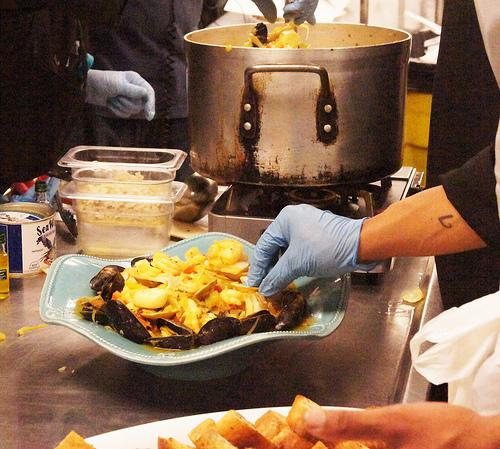Question: what else is this?
Choices:
A. A plate.
B. A placemat.
C. A napkin.
D. A bowl.
Answer with the letter. Answer: D Question: what is this?
Choices:
A. Bathroom.
B. Hallway.
C. Patio.
D. Kitchen.
Answer with the letter. Answer: D Question: what are they wearing?
Choices:
A. Mittens.
B. Hats.
C. Scarves.
D. Gloves.
Answer with the letter. Answer: D Question: how many pots are visible?
Choices:
A. 1.
B. 2.
C. 3.
D. 4.
Answer with the letter. Answer: A Question: where is the photo taken?
Choices:
A. Restaurant Kitchen.
B. Patio.
C. Banquet hall.
D. Hotel.
Answer with the letter. Answer: A Question: what color is the plastic glove?
Choices:
A. Yellow.
B. Orange.
C. Red.
D. Blue.
Answer with the letter. Answer: D Question: who is preparing the food?
Choices:
A. The Chef.
B. The woman.
C. A man.
D. A teenager.
Answer with the letter. Answer: A Question: where is the tattoo?
Choices:
A. On the woman's leg.
B. On the  man's back.
C. On the man's arm.
D. On the person's hand.
Answer with the letter. Answer: C Question: what color is the chef's outfit?
Choices:
A. White.
B. Grey.
C. Red.
D. Black.
Answer with the letter. Answer: D Question: where is this scene?
Choices:
A. Inside a restaurant on a stove.
B. Emergency room.
C. Hospital.
D. Airport.
Answer with the letter. Answer: A 